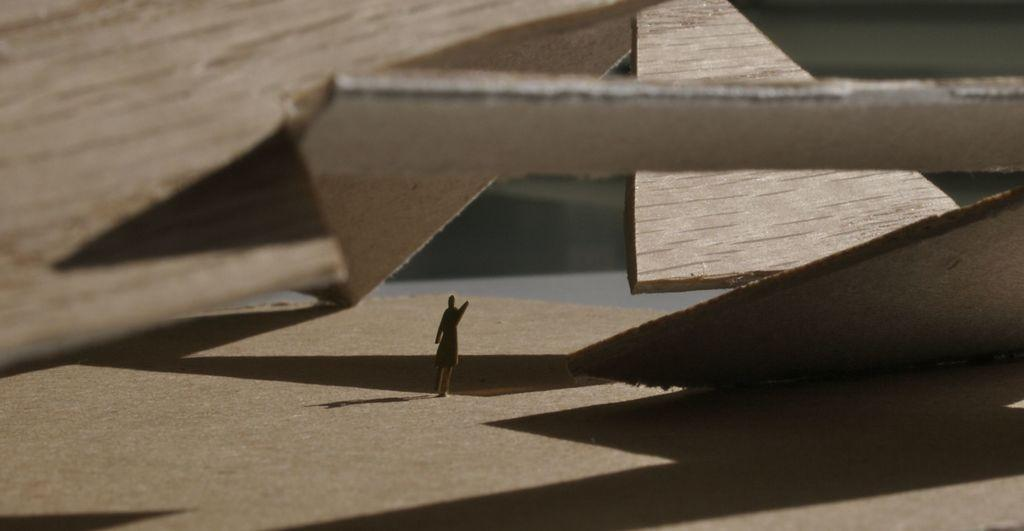What material is present in the image? There is wood in the picture. What can be seen in the middle of the image? There is a shape resembling a person in the middle of the picture. How would you describe the background of the image? The background of the image is blurred. Is there a mask being used by the carpenter in the image? There is no carpenter or mask present in the image. What type of whip is being used by the person in the image? There is no whip or person visible in the image; only a shape resembling a person is present. 